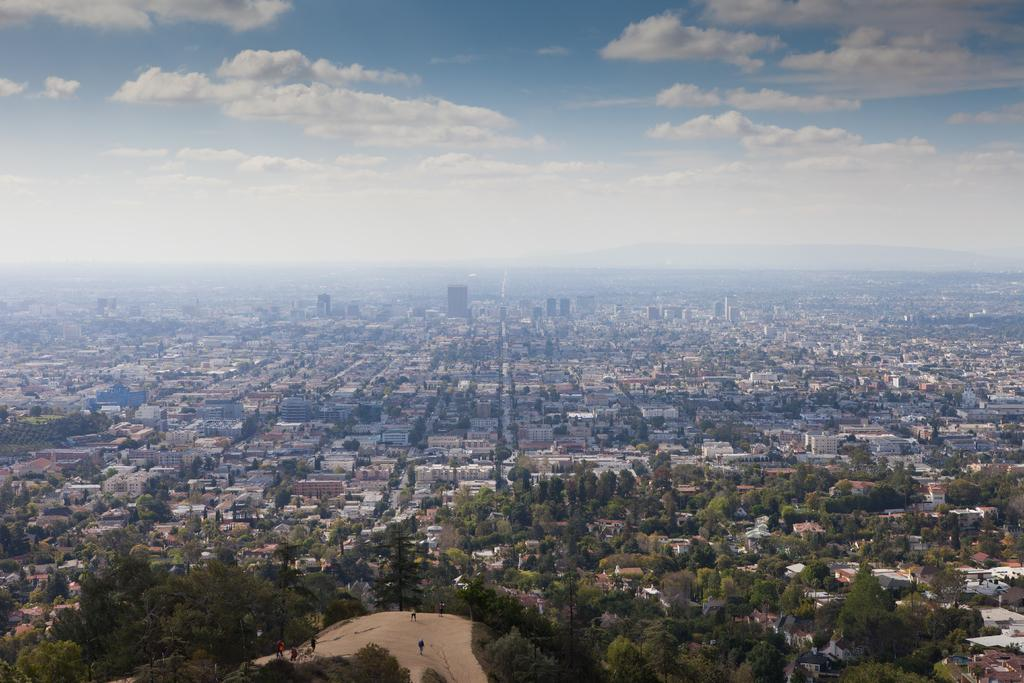What city is depicted in the image? The image contains Los Angeles. What part of the natural environment is visible in the image? There are trees at the bottom of the image. What is visible at the top of the image? There is sky visible at the top of the image. How many clams can be seen on the beach in the image? There is no beach or clams present in the image; it features Los Angeles. What type of crow is perched on the building in the image? There is no crow present in the image; it only shows Los Angeles with trees and sky. 